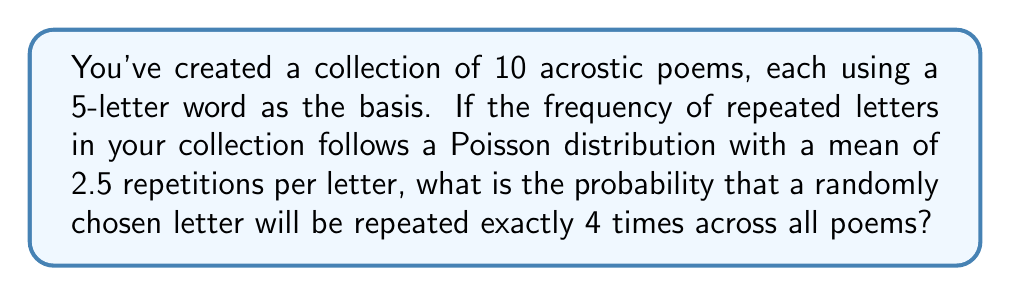Solve this math problem. Let's approach this step-by-step:

1) In a Poisson distribution, the probability of an event occurring $k$ times in a fixed interval is given by the formula:

   $$P(X = k) = \frac{e^{-\lambda}\lambda^k}{k!}$$

   where $\lambda$ is the average number of occurrences.

2) In this case:
   $\lambda = 2.5$ (mean repetitions per letter)
   $k = 4$ (we're looking for exactly 4 repetitions)

3) Let's substitute these values into the formula:

   $$P(X = 4) = \frac{e^{-2.5}(2.5)^4}{4!}$$

4) Now, let's calculate this step-by-step:
   
   a) First, $e^{-2.5} \approx 0.0821$
   
   b) $(2.5)^4 = 39.0625$
   
   c) $4! = 4 \times 3 \times 2 \times 1 = 24$

5) Putting it all together:

   $$P(X = 4) = \frac{0.0821 \times 39.0625}{24} \approx 0.1336$$

6) Therefore, the probability is approximately 0.1336 or 13.36%.
Answer: $0.1336$ or $13.36\%$ 